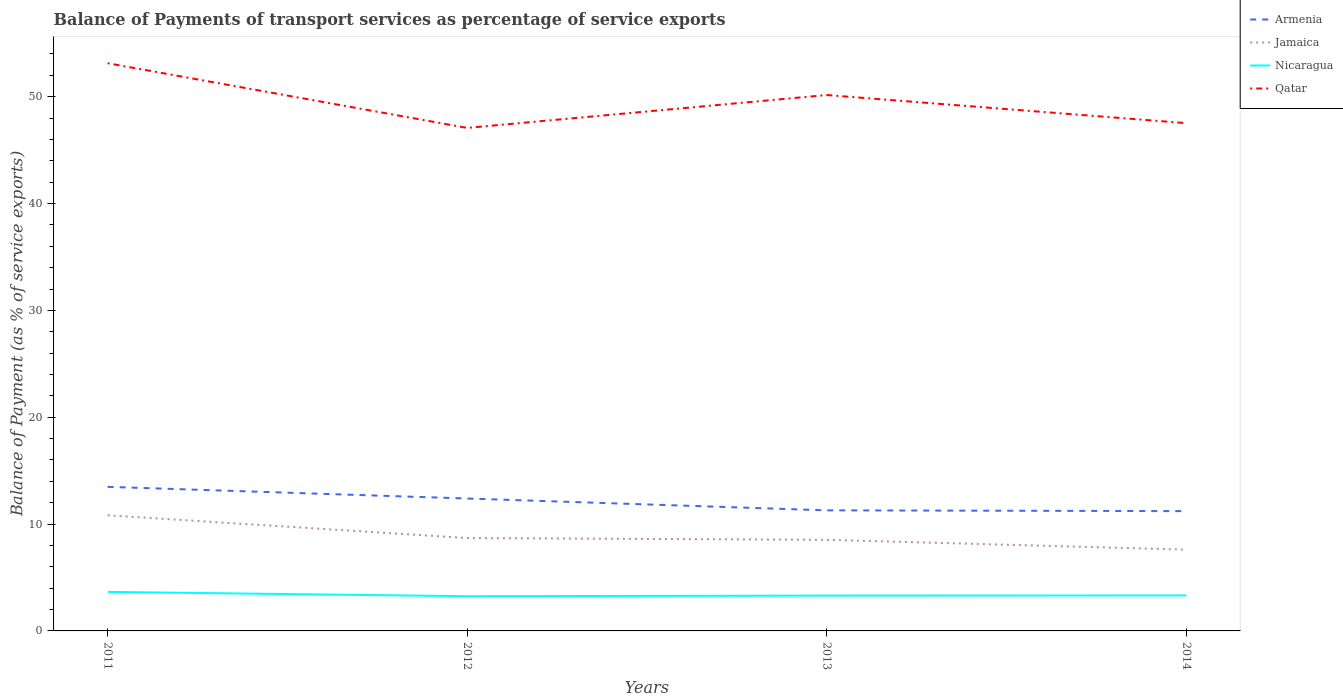Does the line corresponding to Armenia intersect with the line corresponding to Jamaica?
Provide a succinct answer. No. Across all years, what is the maximum balance of payments of transport services in Nicaragua?
Keep it short and to the point. 3.25. In which year was the balance of payments of transport services in Armenia maximum?
Provide a succinct answer. 2014. What is the total balance of payments of transport services in Qatar in the graph?
Give a very brief answer. -0.45. What is the difference between the highest and the second highest balance of payments of transport services in Jamaica?
Make the answer very short. 3.22. How many lines are there?
Provide a succinct answer. 4. How many years are there in the graph?
Your answer should be very brief. 4. Are the values on the major ticks of Y-axis written in scientific E-notation?
Give a very brief answer. No. Does the graph contain any zero values?
Your answer should be very brief. No. Does the graph contain grids?
Offer a very short reply. No. Where does the legend appear in the graph?
Ensure brevity in your answer.  Top right. What is the title of the graph?
Provide a succinct answer. Balance of Payments of transport services as percentage of service exports. What is the label or title of the X-axis?
Keep it short and to the point. Years. What is the label or title of the Y-axis?
Offer a very short reply. Balance of Payment (as % of service exports). What is the Balance of Payment (as % of service exports) of Armenia in 2011?
Your answer should be very brief. 13.49. What is the Balance of Payment (as % of service exports) of Jamaica in 2011?
Your response must be concise. 10.82. What is the Balance of Payment (as % of service exports) of Nicaragua in 2011?
Make the answer very short. 3.65. What is the Balance of Payment (as % of service exports) of Qatar in 2011?
Give a very brief answer. 53.13. What is the Balance of Payment (as % of service exports) of Armenia in 2012?
Give a very brief answer. 12.39. What is the Balance of Payment (as % of service exports) in Jamaica in 2012?
Your answer should be compact. 8.69. What is the Balance of Payment (as % of service exports) of Nicaragua in 2012?
Provide a short and direct response. 3.25. What is the Balance of Payment (as % of service exports) of Qatar in 2012?
Your response must be concise. 47.08. What is the Balance of Payment (as % of service exports) in Armenia in 2013?
Provide a short and direct response. 11.29. What is the Balance of Payment (as % of service exports) in Jamaica in 2013?
Make the answer very short. 8.53. What is the Balance of Payment (as % of service exports) of Nicaragua in 2013?
Offer a terse response. 3.31. What is the Balance of Payment (as % of service exports) in Qatar in 2013?
Your answer should be very brief. 50.16. What is the Balance of Payment (as % of service exports) of Armenia in 2014?
Keep it short and to the point. 11.21. What is the Balance of Payment (as % of service exports) of Jamaica in 2014?
Give a very brief answer. 7.6. What is the Balance of Payment (as % of service exports) of Nicaragua in 2014?
Keep it short and to the point. 3.32. What is the Balance of Payment (as % of service exports) in Qatar in 2014?
Ensure brevity in your answer.  47.53. Across all years, what is the maximum Balance of Payment (as % of service exports) of Armenia?
Offer a terse response. 13.49. Across all years, what is the maximum Balance of Payment (as % of service exports) of Jamaica?
Offer a very short reply. 10.82. Across all years, what is the maximum Balance of Payment (as % of service exports) of Nicaragua?
Make the answer very short. 3.65. Across all years, what is the maximum Balance of Payment (as % of service exports) of Qatar?
Make the answer very short. 53.13. Across all years, what is the minimum Balance of Payment (as % of service exports) of Armenia?
Provide a succinct answer. 11.21. Across all years, what is the minimum Balance of Payment (as % of service exports) in Jamaica?
Provide a short and direct response. 7.6. Across all years, what is the minimum Balance of Payment (as % of service exports) in Nicaragua?
Keep it short and to the point. 3.25. Across all years, what is the minimum Balance of Payment (as % of service exports) of Qatar?
Make the answer very short. 47.08. What is the total Balance of Payment (as % of service exports) of Armenia in the graph?
Your answer should be compact. 48.38. What is the total Balance of Payment (as % of service exports) in Jamaica in the graph?
Keep it short and to the point. 35.65. What is the total Balance of Payment (as % of service exports) of Nicaragua in the graph?
Give a very brief answer. 13.53. What is the total Balance of Payment (as % of service exports) in Qatar in the graph?
Offer a terse response. 197.9. What is the difference between the Balance of Payment (as % of service exports) of Armenia in 2011 and that in 2012?
Your answer should be compact. 1.09. What is the difference between the Balance of Payment (as % of service exports) in Jamaica in 2011 and that in 2012?
Provide a succinct answer. 2.13. What is the difference between the Balance of Payment (as % of service exports) of Nicaragua in 2011 and that in 2012?
Provide a short and direct response. 0.41. What is the difference between the Balance of Payment (as % of service exports) of Qatar in 2011 and that in 2012?
Your response must be concise. 6.05. What is the difference between the Balance of Payment (as % of service exports) of Armenia in 2011 and that in 2013?
Your response must be concise. 2.2. What is the difference between the Balance of Payment (as % of service exports) of Jamaica in 2011 and that in 2013?
Offer a terse response. 2.29. What is the difference between the Balance of Payment (as % of service exports) of Nicaragua in 2011 and that in 2013?
Offer a terse response. 0.35. What is the difference between the Balance of Payment (as % of service exports) in Qatar in 2011 and that in 2013?
Provide a short and direct response. 2.98. What is the difference between the Balance of Payment (as % of service exports) of Armenia in 2011 and that in 2014?
Offer a very short reply. 2.27. What is the difference between the Balance of Payment (as % of service exports) in Jamaica in 2011 and that in 2014?
Provide a short and direct response. 3.22. What is the difference between the Balance of Payment (as % of service exports) of Nicaragua in 2011 and that in 2014?
Give a very brief answer. 0.33. What is the difference between the Balance of Payment (as % of service exports) of Qatar in 2011 and that in 2014?
Provide a short and direct response. 5.61. What is the difference between the Balance of Payment (as % of service exports) in Armenia in 2012 and that in 2013?
Provide a short and direct response. 1.11. What is the difference between the Balance of Payment (as % of service exports) in Jamaica in 2012 and that in 2013?
Ensure brevity in your answer.  0.17. What is the difference between the Balance of Payment (as % of service exports) of Nicaragua in 2012 and that in 2013?
Keep it short and to the point. -0.06. What is the difference between the Balance of Payment (as % of service exports) of Qatar in 2012 and that in 2013?
Ensure brevity in your answer.  -3.08. What is the difference between the Balance of Payment (as % of service exports) of Armenia in 2012 and that in 2014?
Provide a short and direct response. 1.18. What is the difference between the Balance of Payment (as % of service exports) in Jamaica in 2012 and that in 2014?
Provide a succinct answer. 1.09. What is the difference between the Balance of Payment (as % of service exports) of Nicaragua in 2012 and that in 2014?
Your answer should be compact. -0.07. What is the difference between the Balance of Payment (as % of service exports) in Qatar in 2012 and that in 2014?
Your answer should be very brief. -0.45. What is the difference between the Balance of Payment (as % of service exports) of Armenia in 2013 and that in 2014?
Keep it short and to the point. 0.07. What is the difference between the Balance of Payment (as % of service exports) in Jamaica in 2013 and that in 2014?
Offer a terse response. 0.92. What is the difference between the Balance of Payment (as % of service exports) of Nicaragua in 2013 and that in 2014?
Give a very brief answer. -0.01. What is the difference between the Balance of Payment (as % of service exports) of Qatar in 2013 and that in 2014?
Provide a succinct answer. 2.63. What is the difference between the Balance of Payment (as % of service exports) of Armenia in 2011 and the Balance of Payment (as % of service exports) of Jamaica in 2012?
Offer a terse response. 4.79. What is the difference between the Balance of Payment (as % of service exports) in Armenia in 2011 and the Balance of Payment (as % of service exports) in Nicaragua in 2012?
Your answer should be compact. 10.24. What is the difference between the Balance of Payment (as % of service exports) of Armenia in 2011 and the Balance of Payment (as % of service exports) of Qatar in 2012?
Keep it short and to the point. -33.6. What is the difference between the Balance of Payment (as % of service exports) of Jamaica in 2011 and the Balance of Payment (as % of service exports) of Nicaragua in 2012?
Your answer should be compact. 7.57. What is the difference between the Balance of Payment (as % of service exports) of Jamaica in 2011 and the Balance of Payment (as % of service exports) of Qatar in 2012?
Provide a succinct answer. -36.26. What is the difference between the Balance of Payment (as % of service exports) in Nicaragua in 2011 and the Balance of Payment (as % of service exports) in Qatar in 2012?
Your answer should be very brief. -43.43. What is the difference between the Balance of Payment (as % of service exports) of Armenia in 2011 and the Balance of Payment (as % of service exports) of Jamaica in 2013?
Your response must be concise. 4.96. What is the difference between the Balance of Payment (as % of service exports) of Armenia in 2011 and the Balance of Payment (as % of service exports) of Nicaragua in 2013?
Your answer should be very brief. 10.18. What is the difference between the Balance of Payment (as % of service exports) of Armenia in 2011 and the Balance of Payment (as % of service exports) of Qatar in 2013?
Your answer should be very brief. -36.67. What is the difference between the Balance of Payment (as % of service exports) of Jamaica in 2011 and the Balance of Payment (as % of service exports) of Nicaragua in 2013?
Make the answer very short. 7.52. What is the difference between the Balance of Payment (as % of service exports) in Jamaica in 2011 and the Balance of Payment (as % of service exports) in Qatar in 2013?
Keep it short and to the point. -39.34. What is the difference between the Balance of Payment (as % of service exports) in Nicaragua in 2011 and the Balance of Payment (as % of service exports) in Qatar in 2013?
Provide a short and direct response. -46.5. What is the difference between the Balance of Payment (as % of service exports) of Armenia in 2011 and the Balance of Payment (as % of service exports) of Jamaica in 2014?
Offer a very short reply. 5.88. What is the difference between the Balance of Payment (as % of service exports) in Armenia in 2011 and the Balance of Payment (as % of service exports) in Nicaragua in 2014?
Make the answer very short. 10.16. What is the difference between the Balance of Payment (as % of service exports) of Armenia in 2011 and the Balance of Payment (as % of service exports) of Qatar in 2014?
Your answer should be very brief. -34.04. What is the difference between the Balance of Payment (as % of service exports) of Jamaica in 2011 and the Balance of Payment (as % of service exports) of Nicaragua in 2014?
Ensure brevity in your answer.  7.5. What is the difference between the Balance of Payment (as % of service exports) of Jamaica in 2011 and the Balance of Payment (as % of service exports) of Qatar in 2014?
Ensure brevity in your answer.  -36.7. What is the difference between the Balance of Payment (as % of service exports) in Nicaragua in 2011 and the Balance of Payment (as % of service exports) in Qatar in 2014?
Your answer should be compact. -43.87. What is the difference between the Balance of Payment (as % of service exports) in Armenia in 2012 and the Balance of Payment (as % of service exports) in Jamaica in 2013?
Keep it short and to the point. 3.87. What is the difference between the Balance of Payment (as % of service exports) in Armenia in 2012 and the Balance of Payment (as % of service exports) in Nicaragua in 2013?
Your response must be concise. 9.09. What is the difference between the Balance of Payment (as % of service exports) of Armenia in 2012 and the Balance of Payment (as % of service exports) of Qatar in 2013?
Make the answer very short. -37.76. What is the difference between the Balance of Payment (as % of service exports) of Jamaica in 2012 and the Balance of Payment (as % of service exports) of Nicaragua in 2013?
Your answer should be compact. 5.39. What is the difference between the Balance of Payment (as % of service exports) of Jamaica in 2012 and the Balance of Payment (as % of service exports) of Qatar in 2013?
Keep it short and to the point. -41.47. What is the difference between the Balance of Payment (as % of service exports) in Nicaragua in 2012 and the Balance of Payment (as % of service exports) in Qatar in 2013?
Offer a terse response. -46.91. What is the difference between the Balance of Payment (as % of service exports) in Armenia in 2012 and the Balance of Payment (as % of service exports) in Jamaica in 2014?
Make the answer very short. 4.79. What is the difference between the Balance of Payment (as % of service exports) of Armenia in 2012 and the Balance of Payment (as % of service exports) of Nicaragua in 2014?
Provide a succinct answer. 9.07. What is the difference between the Balance of Payment (as % of service exports) in Armenia in 2012 and the Balance of Payment (as % of service exports) in Qatar in 2014?
Make the answer very short. -35.13. What is the difference between the Balance of Payment (as % of service exports) in Jamaica in 2012 and the Balance of Payment (as % of service exports) in Nicaragua in 2014?
Ensure brevity in your answer.  5.37. What is the difference between the Balance of Payment (as % of service exports) in Jamaica in 2012 and the Balance of Payment (as % of service exports) in Qatar in 2014?
Ensure brevity in your answer.  -38.83. What is the difference between the Balance of Payment (as % of service exports) in Nicaragua in 2012 and the Balance of Payment (as % of service exports) in Qatar in 2014?
Your answer should be compact. -44.28. What is the difference between the Balance of Payment (as % of service exports) in Armenia in 2013 and the Balance of Payment (as % of service exports) in Jamaica in 2014?
Your answer should be very brief. 3.68. What is the difference between the Balance of Payment (as % of service exports) in Armenia in 2013 and the Balance of Payment (as % of service exports) in Nicaragua in 2014?
Make the answer very short. 7.97. What is the difference between the Balance of Payment (as % of service exports) in Armenia in 2013 and the Balance of Payment (as % of service exports) in Qatar in 2014?
Your answer should be compact. -36.24. What is the difference between the Balance of Payment (as % of service exports) of Jamaica in 2013 and the Balance of Payment (as % of service exports) of Nicaragua in 2014?
Your answer should be very brief. 5.21. What is the difference between the Balance of Payment (as % of service exports) of Jamaica in 2013 and the Balance of Payment (as % of service exports) of Qatar in 2014?
Offer a very short reply. -39. What is the difference between the Balance of Payment (as % of service exports) of Nicaragua in 2013 and the Balance of Payment (as % of service exports) of Qatar in 2014?
Your response must be concise. -44.22. What is the average Balance of Payment (as % of service exports) of Armenia per year?
Offer a terse response. 12.09. What is the average Balance of Payment (as % of service exports) in Jamaica per year?
Your answer should be very brief. 8.91. What is the average Balance of Payment (as % of service exports) of Nicaragua per year?
Your answer should be compact. 3.38. What is the average Balance of Payment (as % of service exports) of Qatar per year?
Offer a very short reply. 49.47. In the year 2011, what is the difference between the Balance of Payment (as % of service exports) of Armenia and Balance of Payment (as % of service exports) of Jamaica?
Offer a very short reply. 2.66. In the year 2011, what is the difference between the Balance of Payment (as % of service exports) of Armenia and Balance of Payment (as % of service exports) of Nicaragua?
Provide a short and direct response. 9.83. In the year 2011, what is the difference between the Balance of Payment (as % of service exports) in Armenia and Balance of Payment (as % of service exports) in Qatar?
Provide a short and direct response. -39.65. In the year 2011, what is the difference between the Balance of Payment (as % of service exports) of Jamaica and Balance of Payment (as % of service exports) of Nicaragua?
Provide a short and direct response. 7.17. In the year 2011, what is the difference between the Balance of Payment (as % of service exports) of Jamaica and Balance of Payment (as % of service exports) of Qatar?
Your answer should be very brief. -42.31. In the year 2011, what is the difference between the Balance of Payment (as % of service exports) of Nicaragua and Balance of Payment (as % of service exports) of Qatar?
Provide a short and direct response. -49.48. In the year 2012, what is the difference between the Balance of Payment (as % of service exports) in Armenia and Balance of Payment (as % of service exports) in Jamaica?
Your answer should be compact. 3.7. In the year 2012, what is the difference between the Balance of Payment (as % of service exports) of Armenia and Balance of Payment (as % of service exports) of Nicaragua?
Offer a terse response. 9.15. In the year 2012, what is the difference between the Balance of Payment (as % of service exports) in Armenia and Balance of Payment (as % of service exports) in Qatar?
Ensure brevity in your answer.  -34.69. In the year 2012, what is the difference between the Balance of Payment (as % of service exports) of Jamaica and Balance of Payment (as % of service exports) of Nicaragua?
Ensure brevity in your answer.  5.44. In the year 2012, what is the difference between the Balance of Payment (as % of service exports) of Jamaica and Balance of Payment (as % of service exports) of Qatar?
Offer a very short reply. -38.39. In the year 2012, what is the difference between the Balance of Payment (as % of service exports) of Nicaragua and Balance of Payment (as % of service exports) of Qatar?
Provide a succinct answer. -43.83. In the year 2013, what is the difference between the Balance of Payment (as % of service exports) in Armenia and Balance of Payment (as % of service exports) in Jamaica?
Provide a succinct answer. 2.76. In the year 2013, what is the difference between the Balance of Payment (as % of service exports) in Armenia and Balance of Payment (as % of service exports) in Nicaragua?
Keep it short and to the point. 7.98. In the year 2013, what is the difference between the Balance of Payment (as % of service exports) in Armenia and Balance of Payment (as % of service exports) in Qatar?
Ensure brevity in your answer.  -38.87. In the year 2013, what is the difference between the Balance of Payment (as % of service exports) of Jamaica and Balance of Payment (as % of service exports) of Nicaragua?
Ensure brevity in your answer.  5.22. In the year 2013, what is the difference between the Balance of Payment (as % of service exports) in Jamaica and Balance of Payment (as % of service exports) in Qatar?
Offer a very short reply. -41.63. In the year 2013, what is the difference between the Balance of Payment (as % of service exports) in Nicaragua and Balance of Payment (as % of service exports) in Qatar?
Your answer should be very brief. -46.85. In the year 2014, what is the difference between the Balance of Payment (as % of service exports) of Armenia and Balance of Payment (as % of service exports) of Jamaica?
Your answer should be compact. 3.61. In the year 2014, what is the difference between the Balance of Payment (as % of service exports) of Armenia and Balance of Payment (as % of service exports) of Nicaragua?
Give a very brief answer. 7.89. In the year 2014, what is the difference between the Balance of Payment (as % of service exports) of Armenia and Balance of Payment (as % of service exports) of Qatar?
Provide a succinct answer. -36.31. In the year 2014, what is the difference between the Balance of Payment (as % of service exports) in Jamaica and Balance of Payment (as % of service exports) in Nicaragua?
Ensure brevity in your answer.  4.28. In the year 2014, what is the difference between the Balance of Payment (as % of service exports) in Jamaica and Balance of Payment (as % of service exports) in Qatar?
Ensure brevity in your answer.  -39.92. In the year 2014, what is the difference between the Balance of Payment (as % of service exports) of Nicaragua and Balance of Payment (as % of service exports) of Qatar?
Your answer should be very brief. -44.21. What is the ratio of the Balance of Payment (as % of service exports) of Armenia in 2011 to that in 2012?
Your answer should be compact. 1.09. What is the ratio of the Balance of Payment (as % of service exports) of Jamaica in 2011 to that in 2012?
Offer a very short reply. 1.25. What is the ratio of the Balance of Payment (as % of service exports) of Nicaragua in 2011 to that in 2012?
Provide a short and direct response. 1.12. What is the ratio of the Balance of Payment (as % of service exports) in Qatar in 2011 to that in 2012?
Offer a terse response. 1.13. What is the ratio of the Balance of Payment (as % of service exports) of Armenia in 2011 to that in 2013?
Ensure brevity in your answer.  1.19. What is the ratio of the Balance of Payment (as % of service exports) in Jamaica in 2011 to that in 2013?
Make the answer very short. 1.27. What is the ratio of the Balance of Payment (as % of service exports) in Nicaragua in 2011 to that in 2013?
Offer a very short reply. 1.1. What is the ratio of the Balance of Payment (as % of service exports) in Qatar in 2011 to that in 2013?
Your answer should be very brief. 1.06. What is the ratio of the Balance of Payment (as % of service exports) of Armenia in 2011 to that in 2014?
Ensure brevity in your answer.  1.2. What is the ratio of the Balance of Payment (as % of service exports) of Jamaica in 2011 to that in 2014?
Offer a very short reply. 1.42. What is the ratio of the Balance of Payment (as % of service exports) in Nicaragua in 2011 to that in 2014?
Your answer should be very brief. 1.1. What is the ratio of the Balance of Payment (as % of service exports) of Qatar in 2011 to that in 2014?
Keep it short and to the point. 1.12. What is the ratio of the Balance of Payment (as % of service exports) in Armenia in 2012 to that in 2013?
Your answer should be very brief. 1.1. What is the ratio of the Balance of Payment (as % of service exports) in Jamaica in 2012 to that in 2013?
Provide a succinct answer. 1.02. What is the ratio of the Balance of Payment (as % of service exports) in Nicaragua in 2012 to that in 2013?
Provide a short and direct response. 0.98. What is the ratio of the Balance of Payment (as % of service exports) in Qatar in 2012 to that in 2013?
Make the answer very short. 0.94. What is the ratio of the Balance of Payment (as % of service exports) in Armenia in 2012 to that in 2014?
Your response must be concise. 1.11. What is the ratio of the Balance of Payment (as % of service exports) of Jamaica in 2012 to that in 2014?
Provide a succinct answer. 1.14. What is the ratio of the Balance of Payment (as % of service exports) of Nicaragua in 2012 to that in 2014?
Offer a terse response. 0.98. What is the ratio of the Balance of Payment (as % of service exports) of Qatar in 2012 to that in 2014?
Give a very brief answer. 0.99. What is the ratio of the Balance of Payment (as % of service exports) of Armenia in 2013 to that in 2014?
Keep it short and to the point. 1.01. What is the ratio of the Balance of Payment (as % of service exports) of Jamaica in 2013 to that in 2014?
Offer a very short reply. 1.12. What is the ratio of the Balance of Payment (as % of service exports) in Nicaragua in 2013 to that in 2014?
Give a very brief answer. 1. What is the ratio of the Balance of Payment (as % of service exports) of Qatar in 2013 to that in 2014?
Offer a terse response. 1.06. What is the difference between the highest and the second highest Balance of Payment (as % of service exports) of Armenia?
Give a very brief answer. 1.09. What is the difference between the highest and the second highest Balance of Payment (as % of service exports) of Jamaica?
Ensure brevity in your answer.  2.13. What is the difference between the highest and the second highest Balance of Payment (as % of service exports) of Nicaragua?
Your answer should be very brief. 0.33. What is the difference between the highest and the second highest Balance of Payment (as % of service exports) in Qatar?
Offer a very short reply. 2.98. What is the difference between the highest and the lowest Balance of Payment (as % of service exports) in Armenia?
Offer a very short reply. 2.27. What is the difference between the highest and the lowest Balance of Payment (as % of service exports) of Jamaica?
Keep it short and to the point. 3.22. What is the difference between the highest and the lowest Balance of Payment (as % of service exports) of Nicaragua?
Offer a terse response. 0.41. What is the difference between the highest and the lowest Balance of Payment (as % of service exports) of Qatar?
Give a very brief answer. 6.05. 